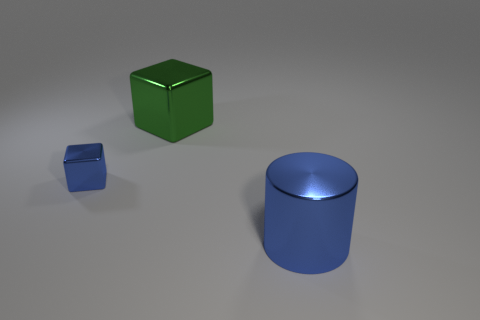Are there any other things that are the same size as the blue cube?
Make the answer very short. No. The green object that is made of the same material as the big blue cylinder is what size?
Provide a succinct answer. Large. There is a object that is both in front of the green metallic thing and on the left side of the large metallic cylinder; what is its color?
Your response must be concise. Blue. Do the shiny object right of the big cube and the blue thing that is to the left of the green metallic thing have the same shape?
Provide a succinct answer. No. What is the material of the big object behind the blue metal cylinder?
Give a very brief answer. Metal. What is the size of the metallic thing that is the same color as the large cylinder?
Your answer should be very brief. Small. What number of objects are metallic objects left of the blue shiny cylinder or large cubes?
Your response must be concise. 2. Are there an equal number of large objects that are to the left of the big blue shiny thing and small brown rubber cylinders?
Provide a short and direct response. No. Is the blue metal cylinder the same size as the green metallic block?
Make the answer very short. Yes. The metallic cylinder that is the same size as the green metal thing is what color?
Keep it short and to the point. Blue. 